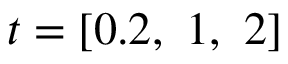<formula> <loc_0><loc_0><loc_500><loc_500>t = [ 0 . 2 , \ 1 , \ 2 ]</formula> 